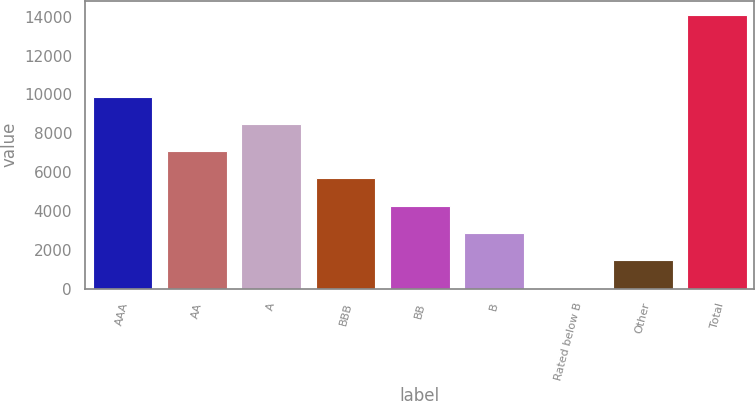Convert chart to OTSL. <chart><loc_0><loc_0><loc_500><loc_500><bar_chart><fcel>AAA<fcel>AA<fcel>A<fcel>BBB<fcel>BB<fcel>B<fcel>Rated below B<fcel>Other<fcel>Total<nl><fcel>9889.58<fcel>7077.7<fcel>8483.64<fcel>5671.76<fcel>4265.82<fcel>2859.88<fcel>48<fcel>1453.94<fcel>14107.4<nl></chart> 